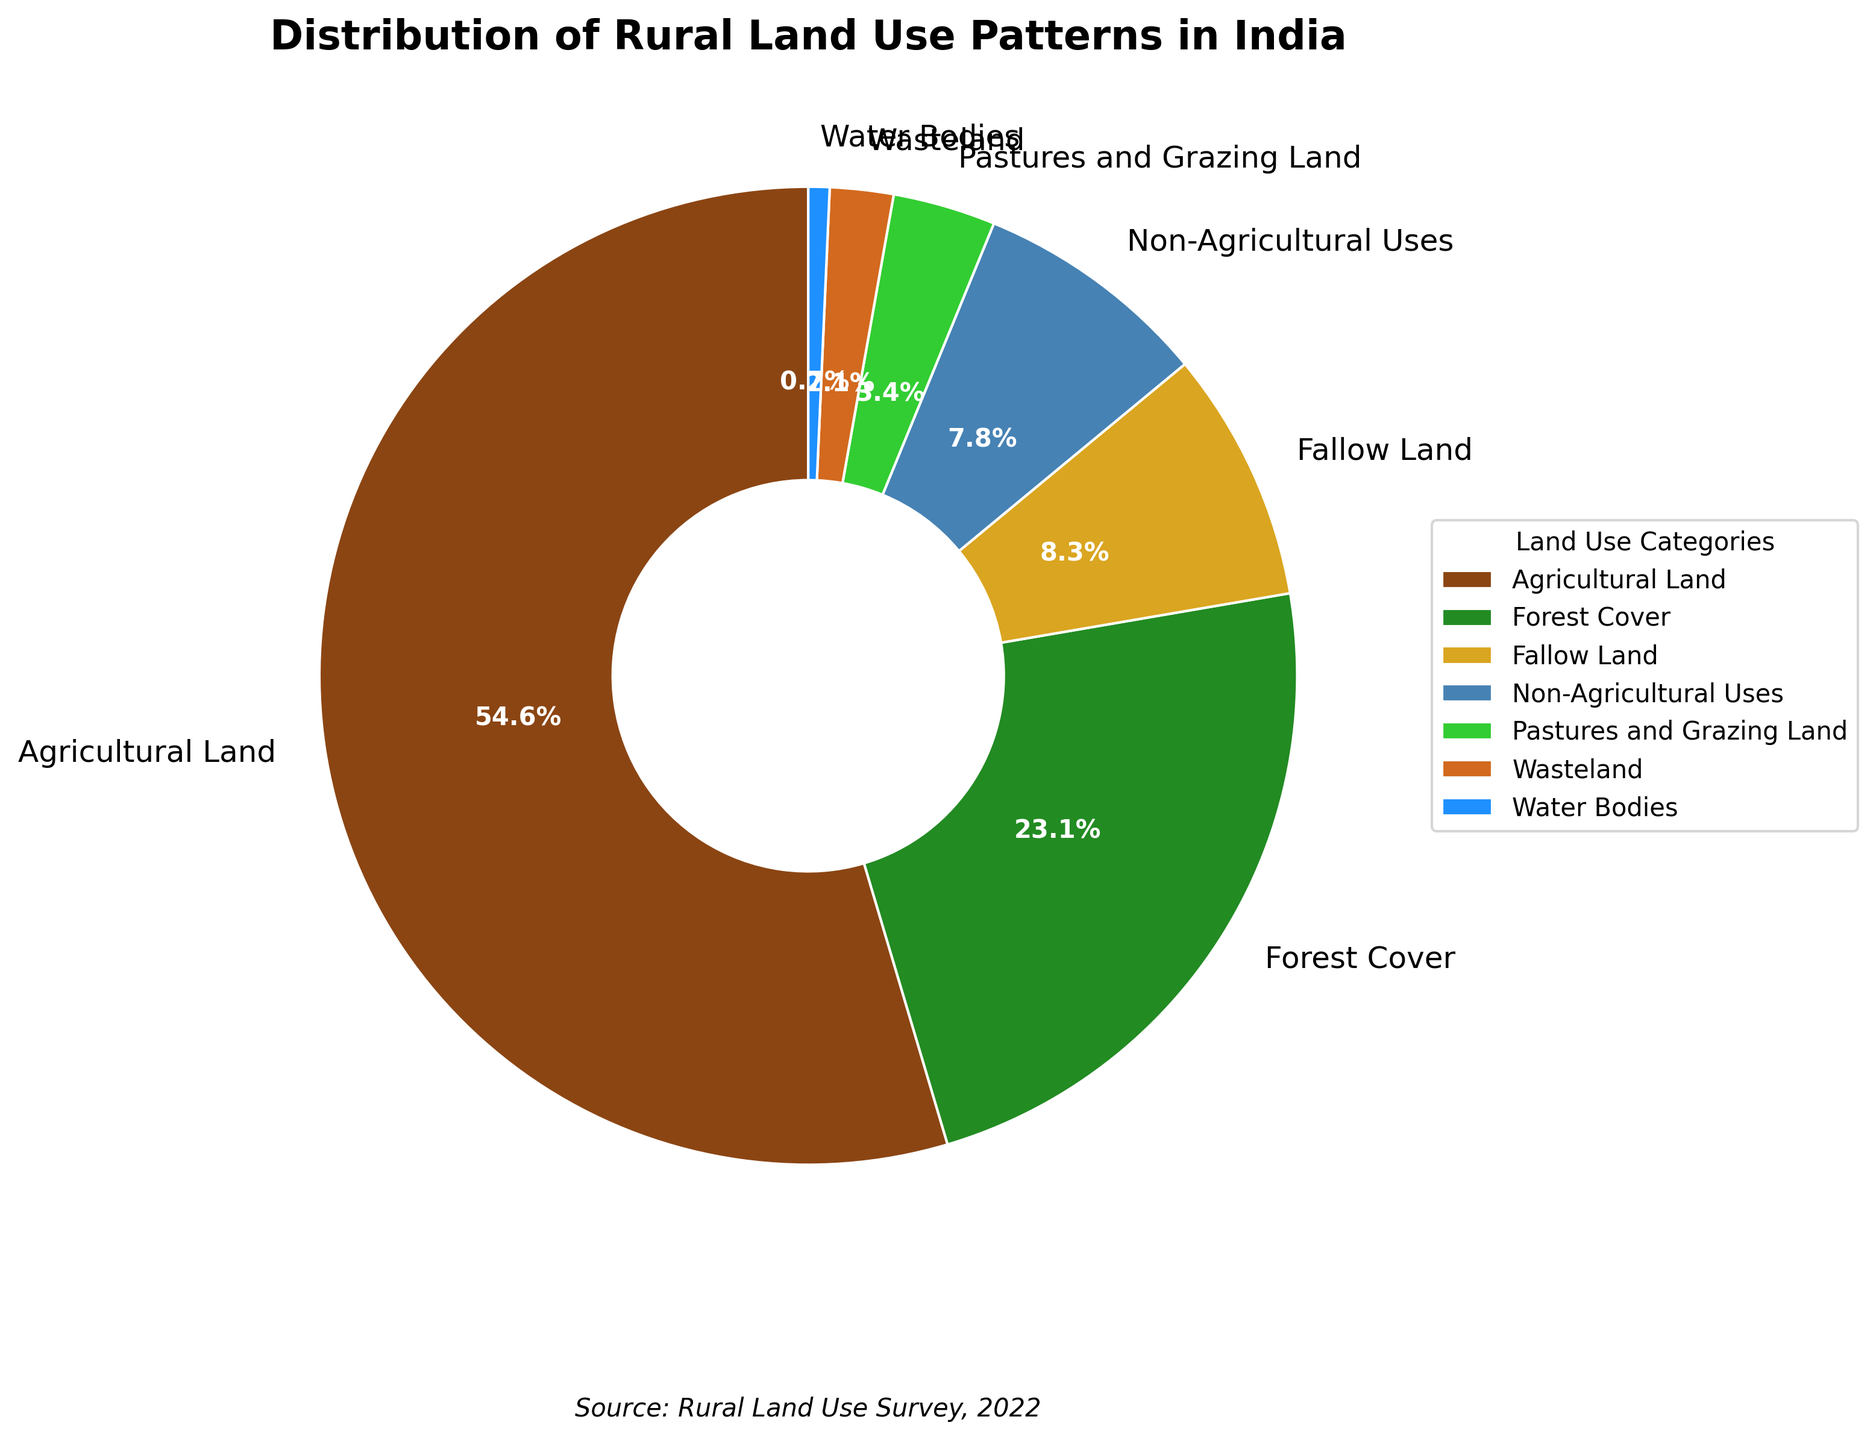What is the category with the highest land use percentage? To identify the category with the highest land use percentage, look at the section of the pie chart with the largest area. The label and percentage will indicate this category. In this case, Agricultural Land has the largest area with 54.6%.
Answer: Agricultural Land What is the total percentage of land used for Forest Cover and Pastures and Grazing Land combined? To calculate the total percentage for Forest Cover and Pastures and Grazing Land, sum their individual percentages: 23.1% + 3.4% = 26.5%.
Answer: 26.5% Which category has a higher percentage of land use: Fallow Land or Non-Agricultural Uses? To determine this, compare the percentages of Fallow Land and Non-Agricultural Uses from the pie chart. Fallow Land has 8.3%, whereas Non-Agricultural Uses has 7.8%. Thus, Fallow Land has a higher percentage.
Answer: Fallow Land What is the difference in land use percentage between Agricultural Land and Forest Cover? Subtract the percentage of Forest Cover from that of Agricultural Land: 54.6% - 23.1% = 31.5%.
Answer: 31.5% Rank the categories from highest to lowest percentage of land use. To rank the categories, arrange their percentages in descending order: Agricultural Land (54.6%), Forest Cover (23.1%), Fallow Land (8.3%), Non-Agricultural Uses (7.8%), Pastures and Grazing Land (3.4%), Wasteland (2.1%), Water Bodies (0.7%).
Answer: Agricultural Land > Forest Cover > Fallow Land > Non-Agricultural Uses > Pastures and Grazing Land > Wasteland > Water Bodies What is the total land use percentage covered by all categories except Agricultural Land? To find this, sum the percentages of all categories except Agricultural Land: 23.1% + 8.3% + 7.8% + 3.4% + 2.1% + 0.7% = 45.4%.
Answer: 45.4% Which sector has the smallest visual segment, and what is its percentage? Identify the category with the smallest section in the pie chart, which is Water Bodies. From the chart, the percentage for Water Bodies is 0.7%.
Answer: Water Bodies, 0.7% What is the combined percentage of Wasteland and Water Bodies? Add the percentages of Wasteland and Water Bodies: 2.1% + 0.7% = 2.8%.
Answer: 2.8% Compare the total percentage of non-productive land (Fallow Land, Wasteland) to Pastures and Grazing Land. Which is higher and by how much? Calculate the total percentage for non-productive land by summing Fallow Land and Wasteland: 8.3% + 2.1% = 10.4%. Then compare it with Pastures and Grazing Land which is 3.4%. The non-productive land total is higher by 10.4% - 3.4% = 7.0%.
Answer: Non-productive land, by 7.0% By how much does the land use for Non-Agricultural Uses exceed that of Water Bodies? Subtract the percentage of Water Bodies from Non-Agricultural Uses: 7.8% - 0.7% = 7.1%.
Answer: 7.1% 